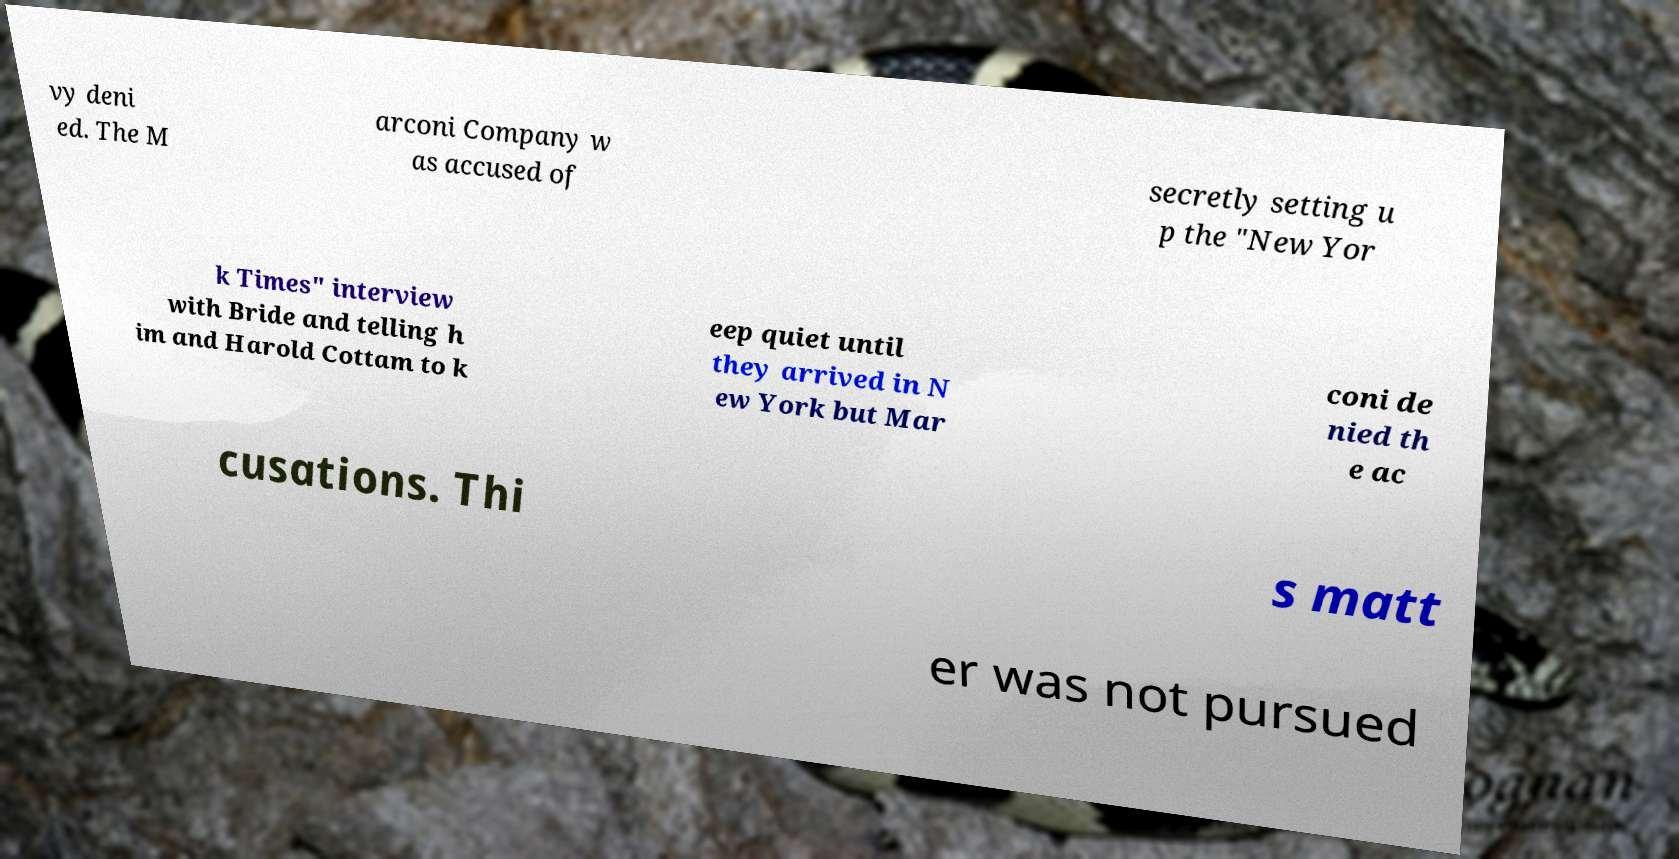Please identify and transcribe the text found in this image. vy deni ed. The M arconi Company w as accused of secretly setting u p the "New Yor k Times" interview with Bride and telling h im and Harold Cottam to k eep quiet until they arrived in N ew York but Mar coni de nied th e ac cusations. Thi s matt er was not pursued 